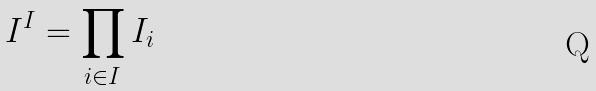<formula> <loc_0><loc_0><loc_500><loc_500>I ^ { I } = \prod _ { i \in I } I _ { i }</formula> 